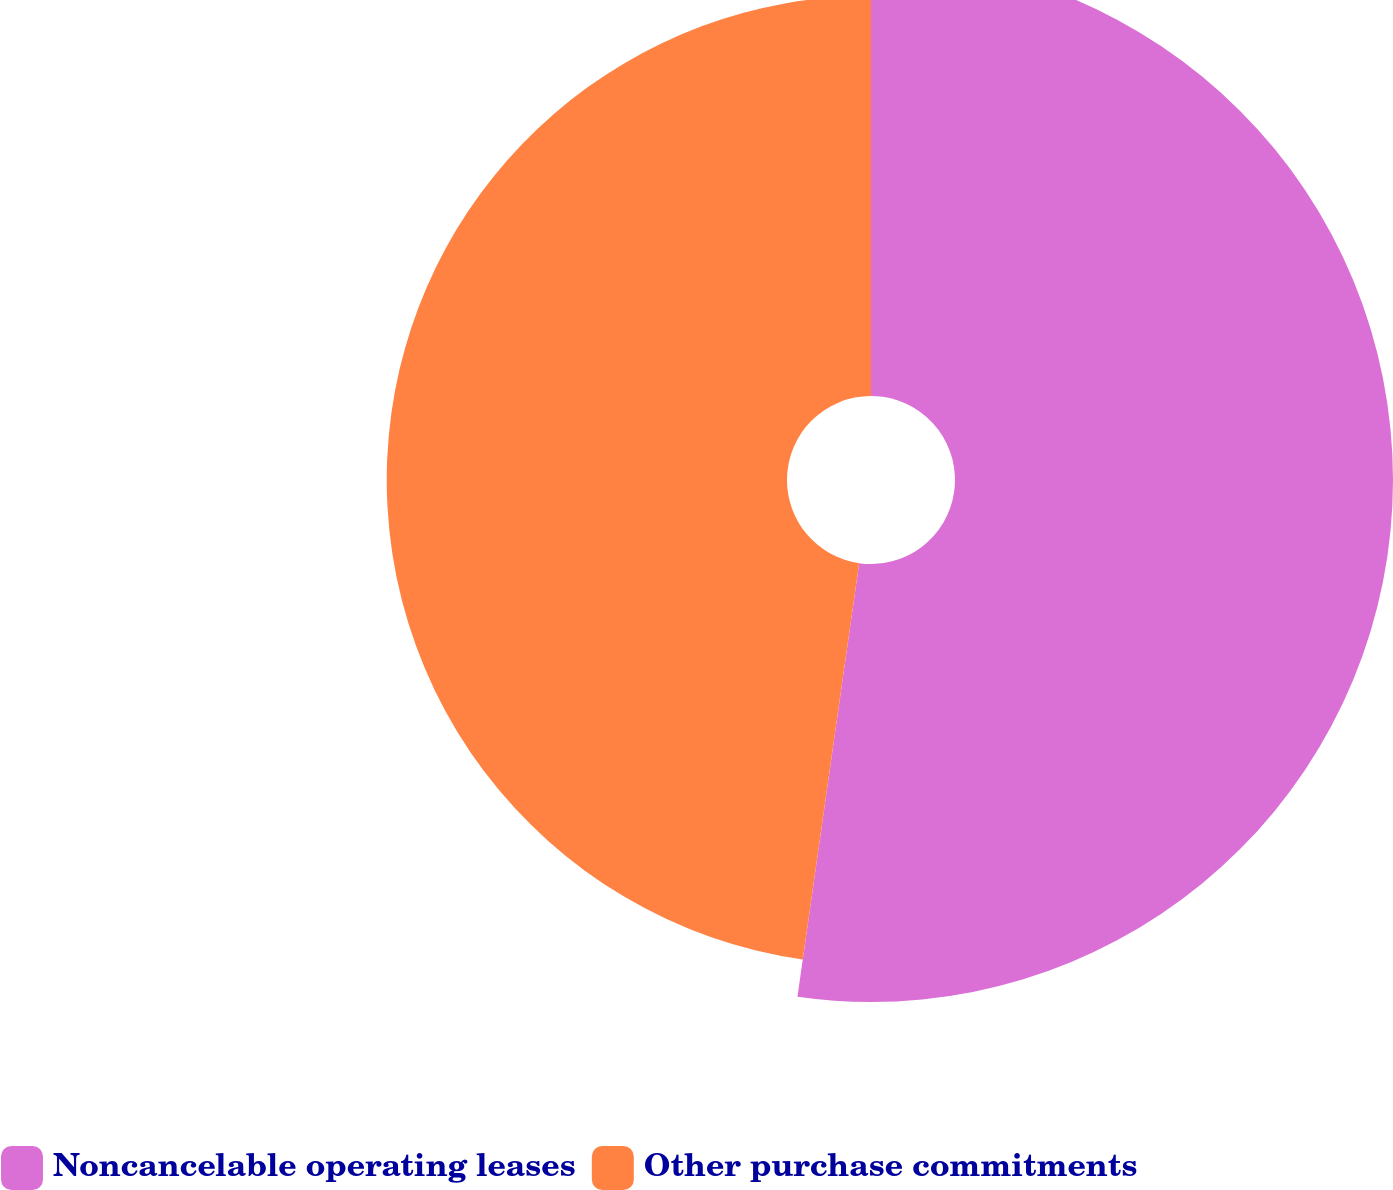<chart> <loc_0><loc_0><loc_500><loc_500><pie_chart><fcel>Noncancelable operating leases<fcel>Other purchase commitments<nl><fcel>52.25%<fcel>47.75%<nl></chart> 